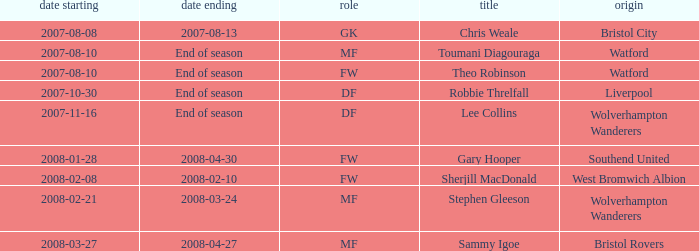What date did Toumani Diagouraga, who played position MF, start? 2007-08-10. 